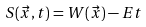<formula> <loc_0><loc_0><loc_500><loc_500>S ( \vec { x } , t ) = W ( \vec { x } ) - E t</formula> 